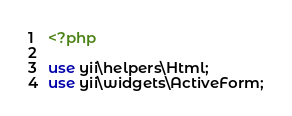<code> <loc_0><loc_0><loc_500><loc_500><_PHP_><?php

use yii\helpers\Html;
use yii\widgets\ActiveForm;
</code> 